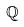<formula> <loc_0><loc_0><loc_500><loc_500>\mathbb { Q }</formula> 